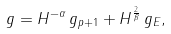<formula> <loc_0><loc_0><loc_500><loc_500>g = H ^ { - \alpha } \, g _ { p + 1 } + H ^ { \frac { 2 } { \beta } } \, g _ { E } ,</formula> 